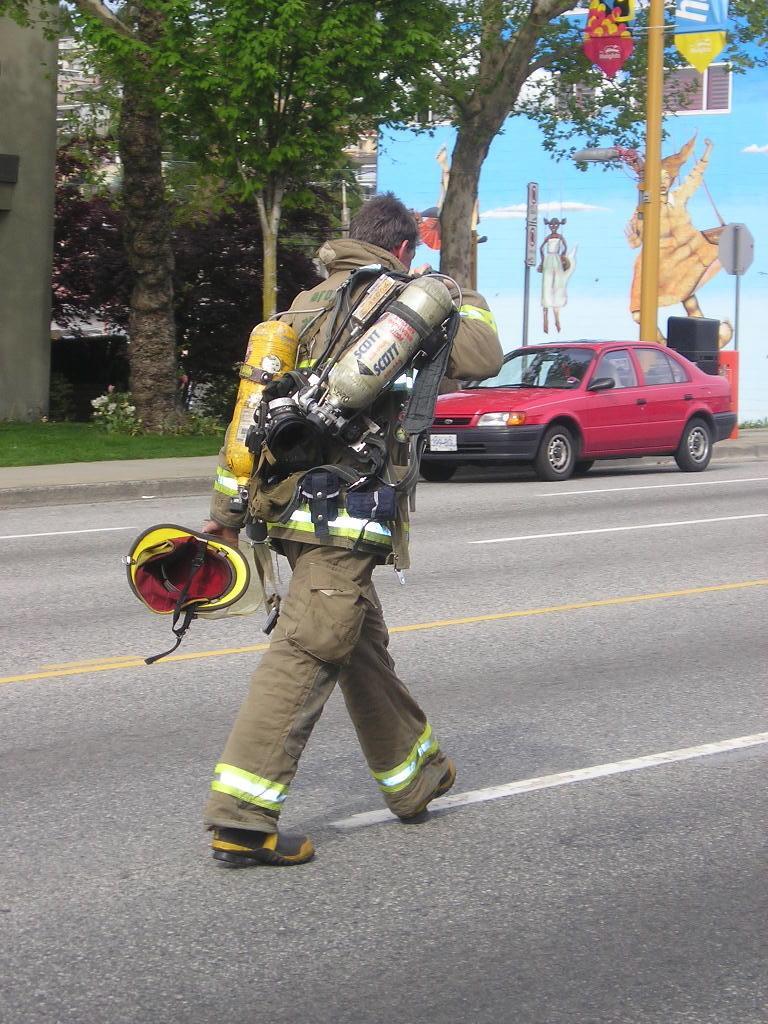Can you describe this image briefly? In the image there is a firefighter walking on the road, in the back there is a car on the side of the footpath with trees and building behind it. 